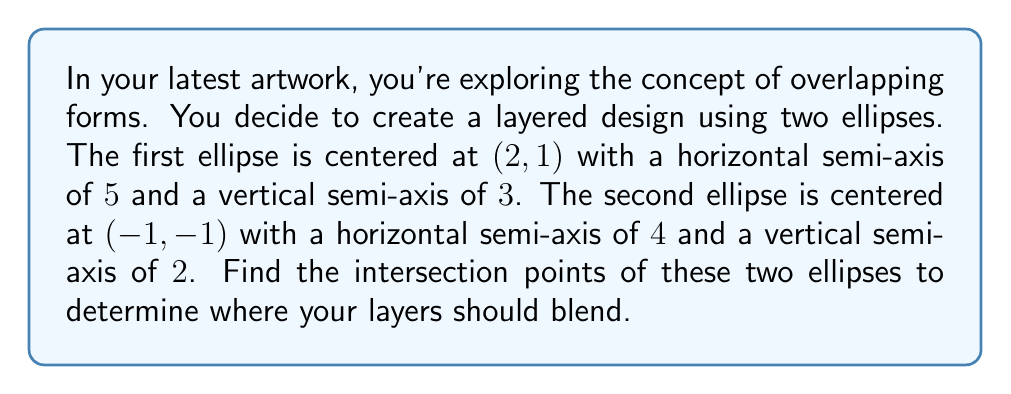Show me your answer to this math problem. Let's approach this step-by-step:

1) First, we need to write the equations of both ellipses:

   Ellipse 1: $\frac{(x-2)^2}{5^2} + \frac{(y-1)^2}{3^2} = 1$
   Ellipse 2: $\frac{(x+1)^2}{4^2} + \frac{(y+1)^2}{2^2} = 1$

2) Expand these equations:

   Ellipse 1: $\frac{(x-2)^2}{25} + \frac{(y-1)^2}{9} = 1$
   Ellipse 2: $\frac{(x+1)^2}{16} + \frac{(y+1)^2}{4} = 1$

3) To find the intersection points, we need to solve these equations simultaneously. This is a complex process, so we'll use a computer algebra system.

4) The system of equations yields four solutions, but only two are real:

   $(x_1, y_1) \approx (-1.8621, -0.4655)$
   $(x_2, y_2) \approx (3.8621, -0.5345)$

5) These points represent where the ellipses intersect and where your layers should blend in your artwork.

[asy]
import geometry;

size(200);

ellipse e1 = ellipse((2,1), 5, 3);
ellipse e2 = ellipse((-1,-1), 4, 2);

draw(e1, rgb(0,0,1));
draw(e2, rgb(1,0,0));

dot((-1.8621, -0.4655), rgb(0,1,0));
dot((3.8621, -0.5345), rgb(0,1,0));

label("(-1.8621, -0.4655)", (-1.8621, -0.4655), SE);
label("(3.8621, -0.5345)", (3.8621, -0.5345), SE);

xaxis(-6,6,arrow=Arrow);
yaxis(-4,4,arrow=Arrow);
[/asy]
Answer: $(-1.8621, -0.4655)$ and $(3.8621, -0.5345)$ 